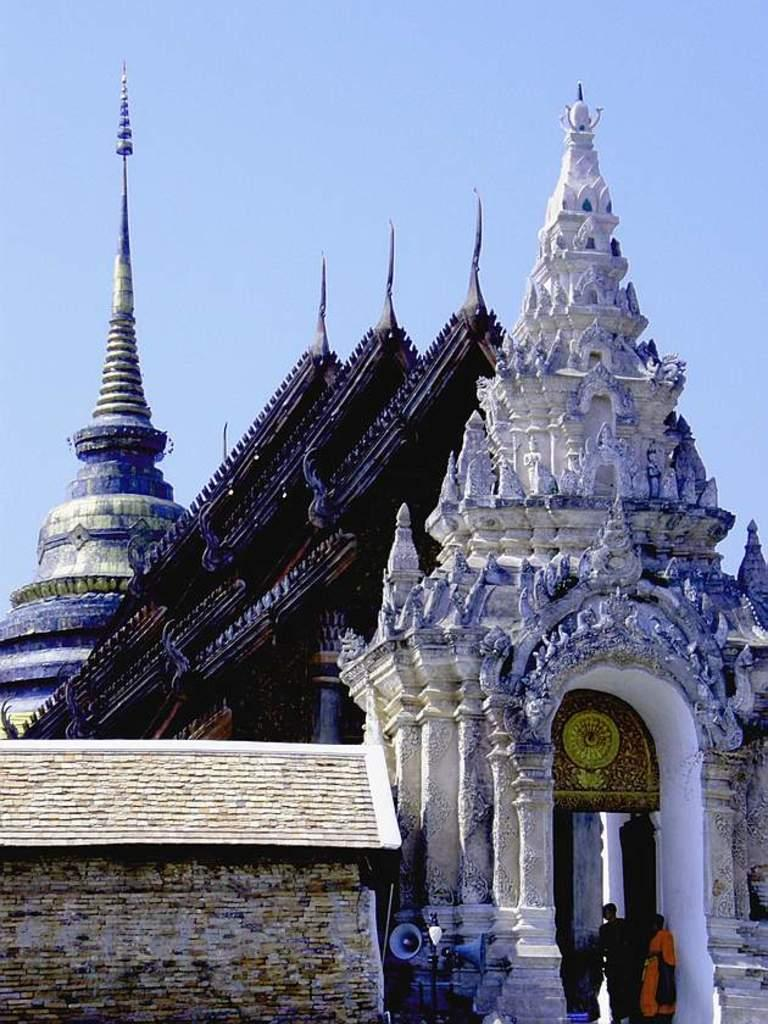What type of structures can be seen in the image? There are buildings in the image. What architectural features are present in the image? There are pillars in the image. What object is used for amplifying sound in the image? There is a speaker in the image. What type of barrier is present in the image? There is a wall in the image. What can be seen in the background of the image? The sky is visible in the background of the image. What type of meat is being twisted on the wheel in the image? There is no meat or wheel present in the image; it features buildings, pillars, a speaker, a wall, and the sky. 